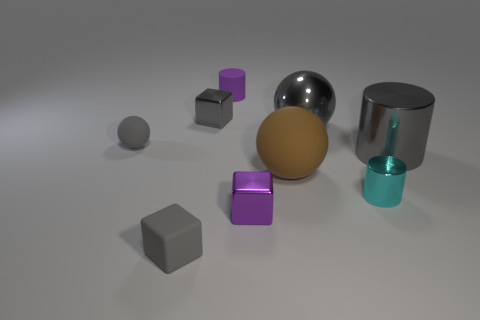There is a cyan shiny cylinder; is its size the same as the cube that is behind the brown sphere?
Offer a very short reply. Yes. There is a small gray object that is to the right of the matte block; what is its shape?
Provide a succinct answer. Cube. There is a small shiny cube in front of the small shiny cube that is behind the purple block; are there any small gray metallic objects that are right of it?
Ensure brevity in your answer.  No. What material is the big gray object that is the same shape as the big brown matte object?
Ensure brevity in your answer.  Metal. Is there any other thing that has the same material as the big brown sphere?
Your response must be concise. Yes. How many blocks are either small gray objects or small purple rubber things?
Provide a short and direct response. 2. There is a purple block in front of the gray metallic cube; is its size the same as the purple rubber cylinder that is to the left of the big brown object?
Keep it short and to the point. Yes. What material is the gray cube in front of the rubber object that is to the left of the small gray matte cube made of?
Keep it short and to the point. Rubber. Is the number of tiny purple blocks that are behind the purple cylinder less than the number of gray cylinders?
Make the answer very short. Yes. There is a small purple thing that is made of the same material as the small gray sphere; what is its shape?
Make the answer very short. Cylinder. 